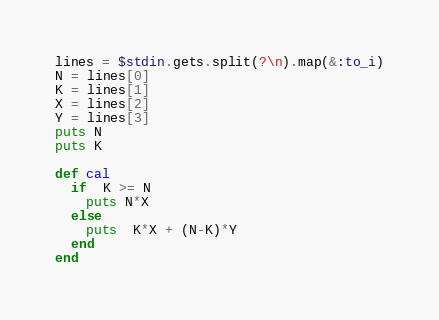<code> <loc_0><loc_0><loc_500><loc_500><_Ruby_>lines = $stdin.gets.split(?\n).map(&:to_i)
N = lines[0]
K = lines[1]
X = lines[2]
Y = lines[3]
puts N
puts K

def cal
  if  K >= N
    puts N*X
  else
    puts  K*X + (N-K)*Y
  end
end</code> 